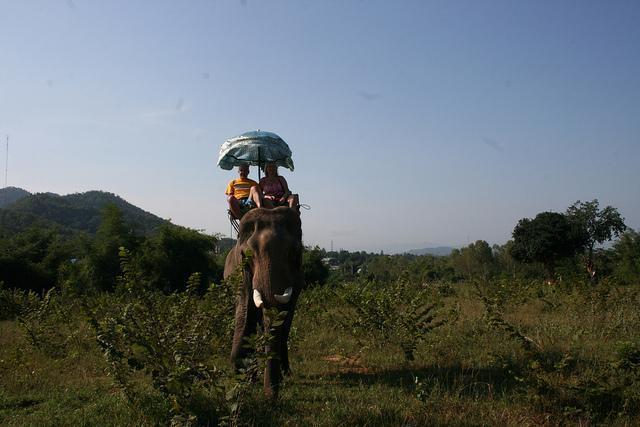What is the umbrella used to block?
Choose the correct response, then elucidate: 'Answer: answer
Rationale: rationale.'
Options: Snow, hail, rain, sun. Answer: sun.
Rationale: The people riding the elephant are carrying an umbrella to protect themselves from the sun's rays. 